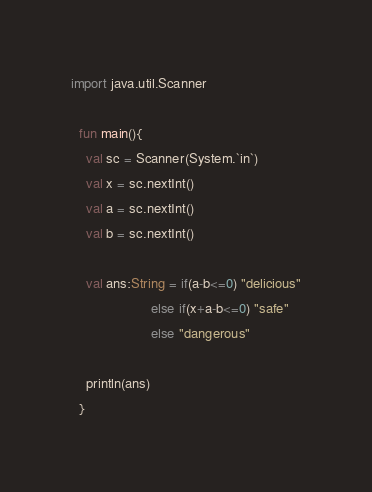<code> <loc_0><loc_0><loc_500><loc_500><_Kotlin_>import java.util.Scanner

  fun main(){
    val sc = Scanner(System.`in`)
    val x = sc.nextInt()
    val a = sc.nextInt()
    val b = sc.nextInt()

    val ans:String = if(a-b<=0) "delicious"
                     else if(x+a-b<=0) "safe"
                     else "dangerous"

    println(ans)
  }</code> 